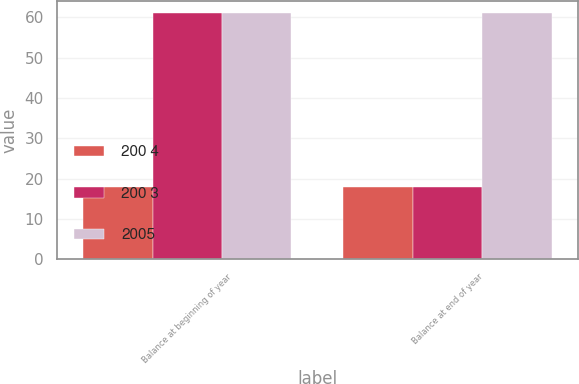Convert chart. <chart><loc_0><loc_0><loc_500><loc_500><stacked_bar_chart><ecel><fcel>Balance at beginning of year<fcel>Balance at end of year<nl><fcel>200 4<fcel>18<fcel>18<nl><fcel>200 3<fcel>61<fcel>18<nl><fcel>2005<fcel>61<fcel>61<nl></chart> 